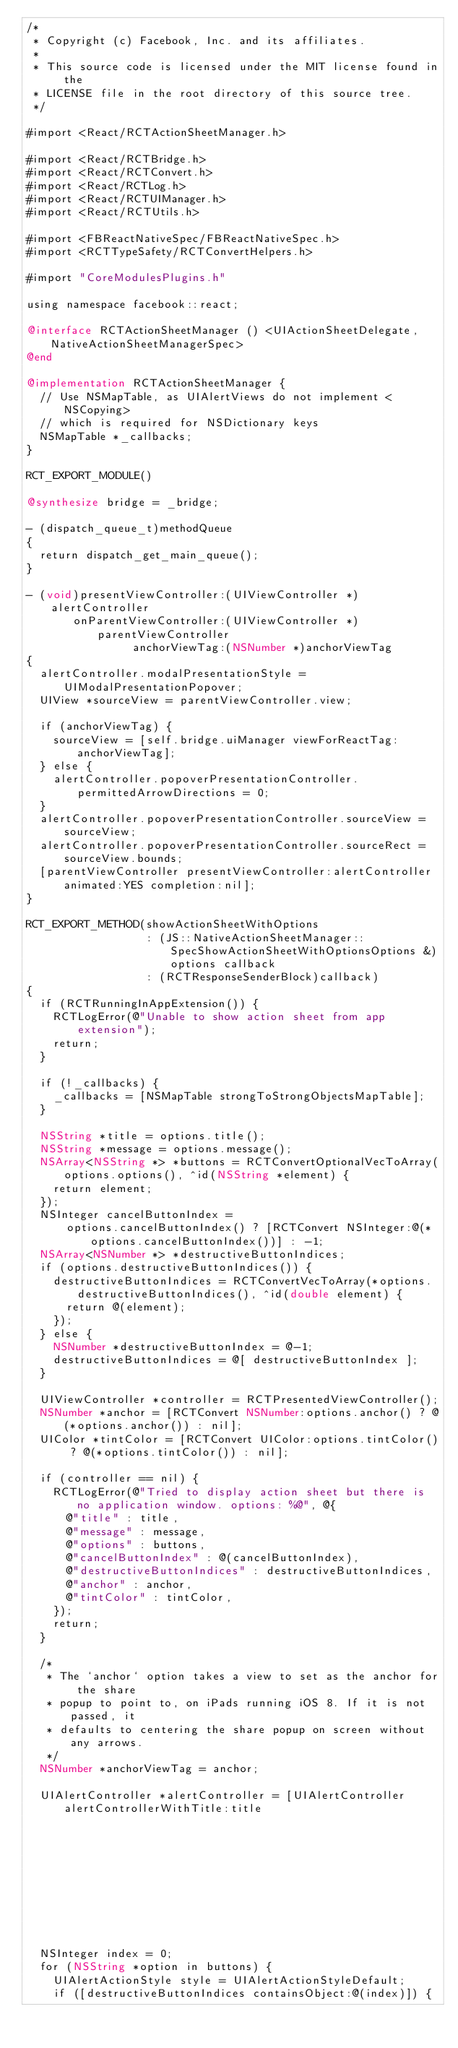<code> <loc_0><loc_0><loc_500><loc_500><_ObjectiveC_>/*
 * Copyright (c) Facebook, Inc. and its affiliates.
 *
 * This source code is licensed under the MIT license found in the
 * LICENSE file in the root directory of this source tree.
 */

#import <React/RCTActionSheetManager.h>

#import <React/RCTBridge.h>
#import <React/RCTConvert.h>
#import <React/RCTLog.h>
#import <React/RCTUIManager.h>
#import <React/RCTUtils.h>

#import <FBReactNativeSpec/FBReactNativeSpec.h>
#import <RCTTypeSafety/RCTConvertHelpers.h>

#import "CoreModulesPlugins.h"

using namespace facebook::react;

@interface RCTActionSheetManager () <UIActionSheetDelegate, NativeActionSheetManagerSpec>
@end

@implementation RCTActionSheetManager {
  // Use NSMapTable, as UIAlertViews do not implement <NSCopying>
  // which is required for NSDictionary keys
  NSMapTable *_callbacks;
}

RCT_EXPORT_MODULE()

@synthesize bridge = _bridge;

- (dispatch_queue_t)methodQueue
{
  return dispatch_get_main_queue();
}

- (void)presentViewController:(UIViewController *)alertController
       onParentViewController:(UIViewController *)parentViewController
                anchorViewTag:(NSNumber *)anchorViewTag
{
  alertController.modalPresentationStyle = UIModalPresentationPopover;
  UIView *sourceView = parentViewController.view;

  if (anchorViewTag) {
    sourceView = [self.bridge.uiManager viewForReactTag:anchorViewTag];
  } else {
    alertController.popoverPresentationController.permittedArrowDirections = 0;
  }
  alertController.popoverPresentationController.sourceView = sourceView;
  alertController.popoverPresentationController.sourceRect = sourceView.bounds;
  [parentViewController presentViewController:alertController animated:YES completion:nil];
}

RCT_EXPORT_METHOD(showActionSheetWithOptions
                  : (JS::NativeActionSheetManager::SpecShowActionSheetWithOptionsOptions &)options callback
                  : (RCTResponseSenderBlock)callback)
{
  if (RCTRunningInAppExtension()) {
    RCTLogError(@"Unable to show action sheet from app extension");
    return;
  }

  if (!_callbacks) {
    _callbacks = [NSMapTable strongToStrongObjectsMapTable];
  }

  NSString *title = options.title();
  NSString *message = options.message();
  NSArray<NSString *> *buttons = RCTConvertOptionalVecToArray(options.options(), ^id(NSString *element) {
    return element;
  });
  NSInteger cancelButtonIndex =
      options.cancelButtonIndex() ? [RCTConvert NSInteger:@(*options.cancelButtonIndex())] : -1;
  NSArray<NSNumber *> *destructiveButtonIndices;
  if (options.destructiveButtonIndices()) {
    destructiveButtonIndices = RCTConvertVecToArray(*options.destructiveButtonIndices(), ^id(double element) {
      return @(element);
    });
  } else {
    NSNumber *destructiveButtonIndex = @-1;
    destructiveButtonIndices = @[ destructiveButtonIndex ];
  }

  UIViewController *controller = RCTPresentedViewController();
  NSNumber *anchor = [RCTConvert NSNumber:options.anchor() ? @(*options.anchor()) : nil];
  UIColor *tintColor = [RCTConvert UIColor:options.tintColor() ? @(*options.tintColor()) : nil];

  if (controller == nil) {
    RCTLogError(@"Tried to display action sheet but there is no application window. options: %@", @{
      @"title" : title,
      @"message" : message,
      @"options" : buttons,
      @"cancelButtonIndex" : @(cancelButtonIndex),
      @"destructiveButtonIndices" : destructiveButtonIndices,
      @"anchor" : anchor,
      @"tintColor" : tintColor,
    });
    return;
  }

  /*
   * The `anchor` option takes a view to set as the anchor for the share
   * popup to point to, on iPads running iOS 8. If it is not passed, it
   * defaults to centering the share popup on screen without any arrows.
   */
  NSNumber *anchorViewTag = anchor;

  UIAlertController *alertController = [UIAlertController alertControllerWithTitle:title
                                                                           message:message
                                                                    preferredStyle:UIAlertControllerStyleActionSheet];

  NSInteger index = 0;
  for (NSString *option in buttons) {
    UIAlertActionStyle style = UIAlertActionStyleDefault;
    if ([destructiveButtonIndices containsObject:@(index)]) {</code> 